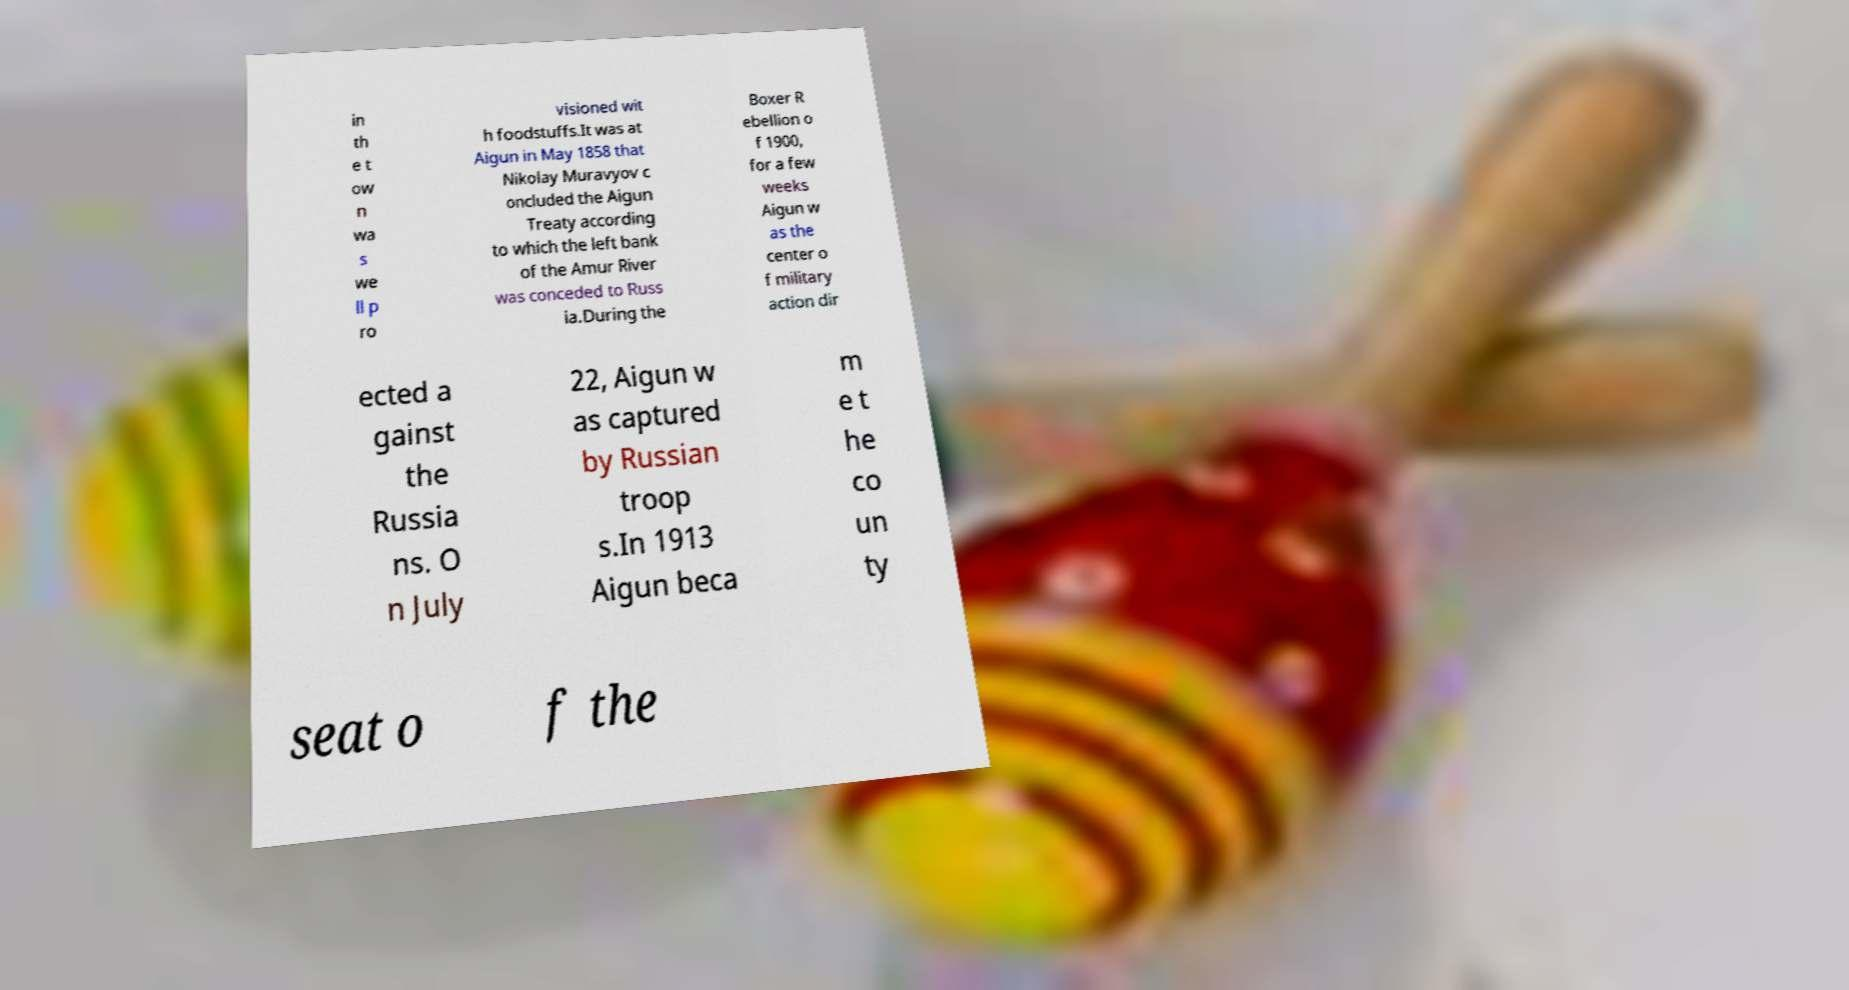I need the written content from this picture converted into text. Can you do that? in th e t ow n wa s we ll p ro visioned wit h foodstuffs.It was at Aigun in May 1858 that Nikolay Muravyov c oncluded the Aigun Treaty according to which the left bank of the Amur River was conceded to Russ ia.During the Boxer R ebellion o f 1900, for a few weeks Aigun w as the center o f military action dir ected a gainst the Russia ns. O n July 22, Aigun w as captured by Russian troop s.In 1913 Aigun beca m e t he co un ty seat o f the 